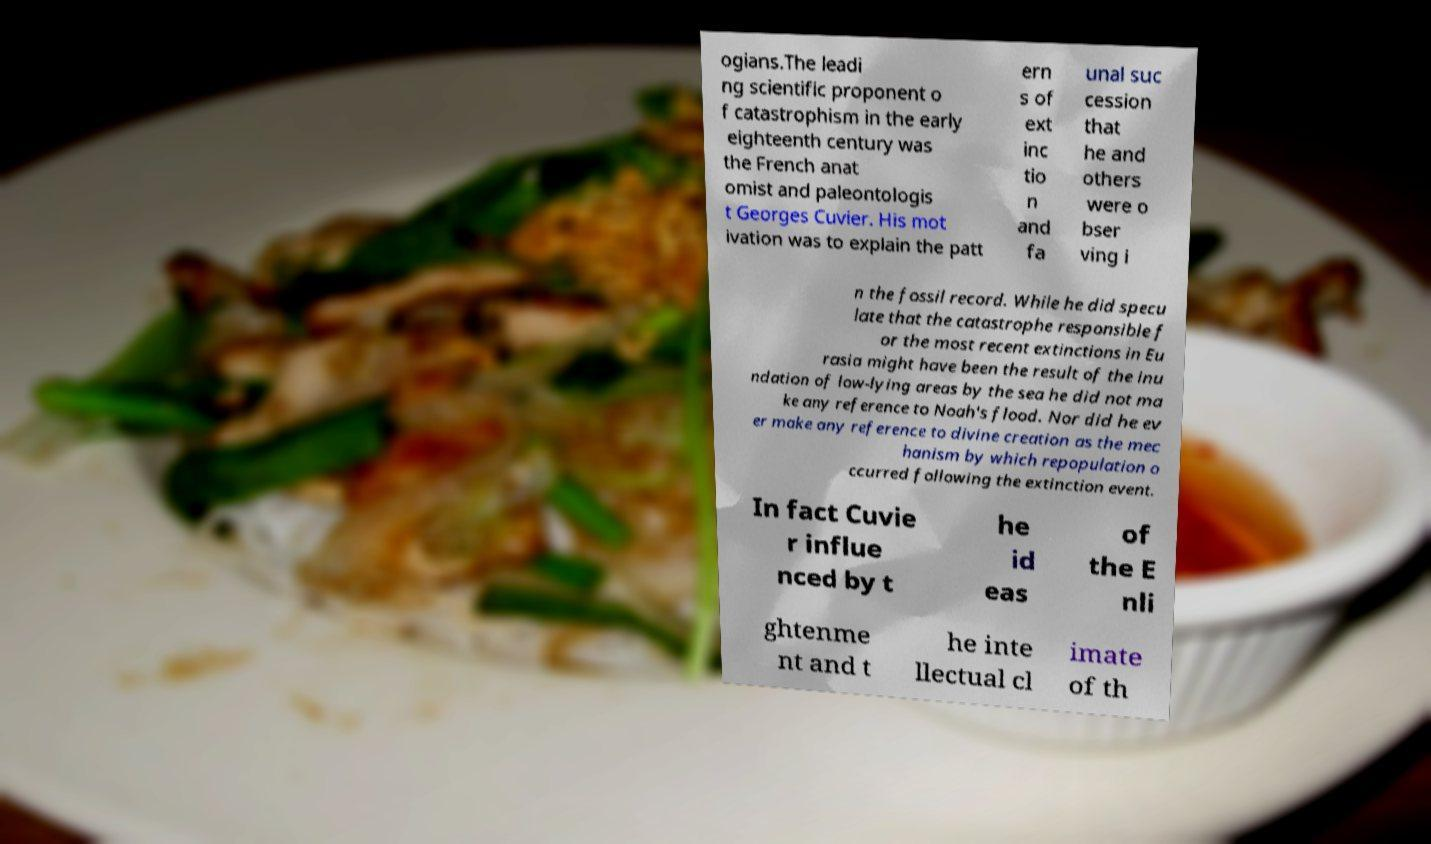Could you extract and type out the text from this image? ogians.The leadi ng scientific proponent o f catastrophism in the early eighteenth century was the French anat omist and paleontologis t Georges Cuvier. His mot ivation was to explain the patt ern s of ext inc tio n and fa unal suc cession that he and others were o bser ving i n the fossil record. While he did specu late that the catastrophe responsible f or the most recent extinctions in Eu rasia might have been the result of the inu ndation of low-lying areas by the sea he did not ma ke any reference to Noah's flood. Nor did he ev er make any reference to divine creation as the mec hanism by which repopulation o ccurred following the extinction event. In fact Cuvie r influe nced by t he id eas of the E nli ghtenme nt and t he inte llectual cl imate of th 